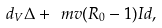<formula> <loc_0><loc_0><loc_500><loc_500>d _ { V } \Delta + \ m v ( R _ { 0 } - 1 ) I d ,</formula> 